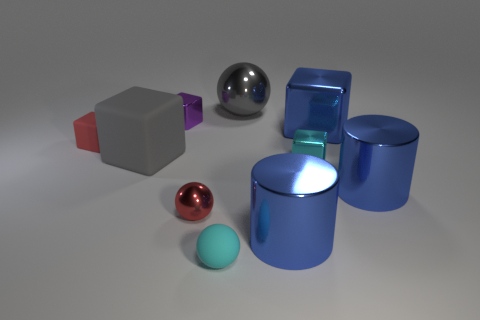Does this image have any particular style or resemble any art form? This image showcases a minimalist style with 3D-rendered geometric shapes, reminiscent of abstract art, focusing on form and color rather than real-world accuracy. 